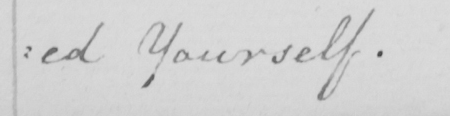What does this handwritten line say? :ed Yourself. 